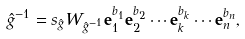Convert formula to latex. <formula><loc_0><loc_0><loc_500><loc_500>\hat { g } ^ { - 1 } = s _ { \hat { g } } W _ { \hat { g } ^ { - 1 } } \mathbf e _ { 1 } ^ { b _ { 1 } } \mathbf e _ { 2 } ^ { b _ { 2 } } \cdots \mathbf e _ { k } ^ { b _ { k } } \cdots \mathbf e _ { n } ^ { b _ { n } } ,</formula> 